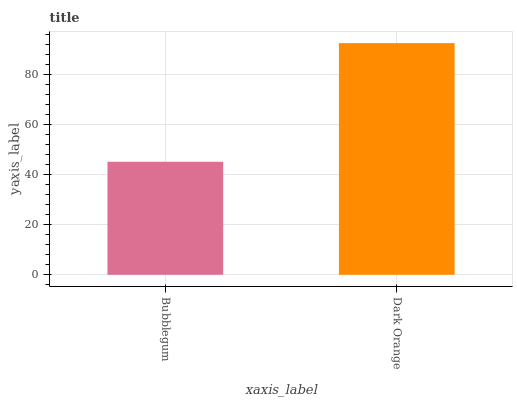Is Bubblegum the minimum?
Answer yes or no. Yes. Is Dark Orange the maximum?
Answer yes or no. Yes. Is Dark Orange the minimum?
Answer yes or no. No. Is Dark Orange greater than Bubblegum?
Answer yes or no. Yes. Is Bubblegum less than Dark Orange?
Answer yes or no. Yes. Is Bubblegum greater than Dark Orange?
Answer yes or no. No. Is Dark Orange less than Bubblegum?
Answer yes or no. No. Is Dark Orange the high median?
Answer yes or no. Yes. Is Bubblegum the low median?
Answer yes or no. Yes. Is Bubblegum the high median?
Answer yes or no. No. Is Dark Orange the low median?
Answer yes or no. No. 